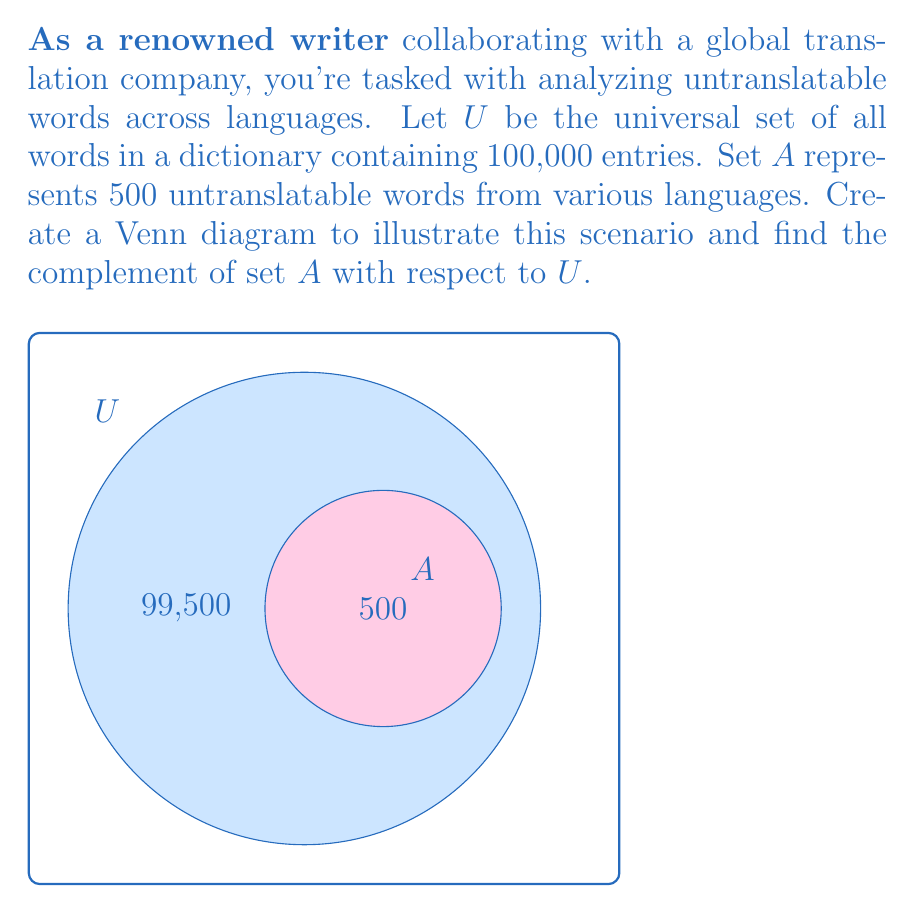What is the answer to this math problem? To solve this problem, let's follow these steps:

1) First, recall that the complement of a set $A$ with respect to the universal set $U$ is denoted as $A^c$ or $U - A$. It contains all elements in $U$ that are not in $A$.

2) We're given:
   $U$ = Universal set (all words in the dictionary) = 100,000 words
   $A$ = Set of untranslatable words = 500 words

3) To find the complement of $A$, we need to subtract the number of elements in $A$ from the number of elements in $U$:

   $$|A^c| = |U| - |A|$$

4) Substituting the values:

   $$|A^c| = 100,000 - 500 = 99,500$$

5) Therefore, the complement of $A$ contains 99,500 words.

6) In set notation, we can express this as:

   $$A^c = \{x \in U : x \notin A\}$$

   Which reads as "the set of all elements $x$ in $U$ such that $x$ is not in $A$."

The Venn diagram in the question visually represents this relationship, with the larger circle representing $U$, the smaller circle representing $A$, and the region outside $A$ but inside $U$ representing $A^c$.
Answer: $A^c = 99,500$ words 